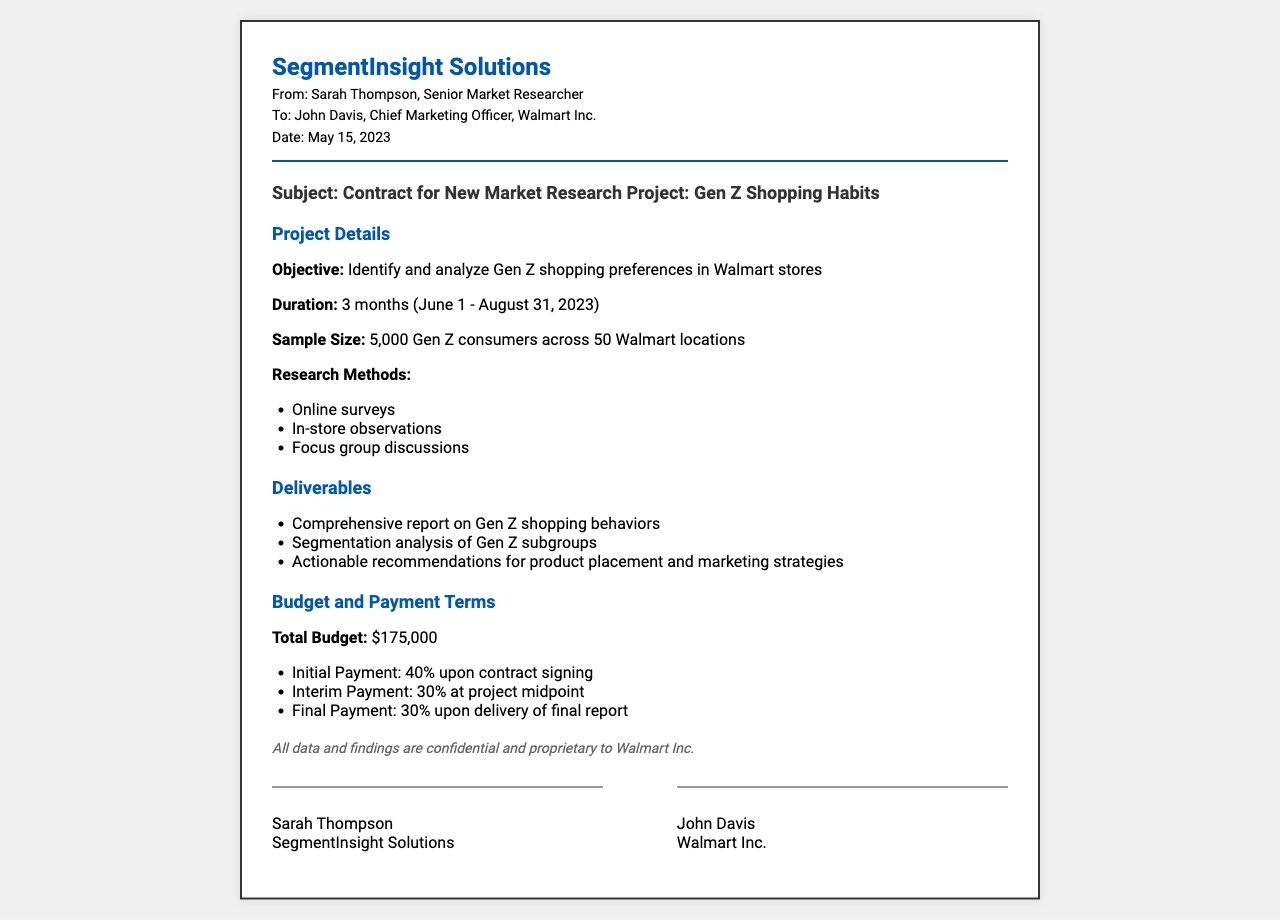What is the objective of the project? The objective is clearly stated in the document as the identification and analysis of Gen Z shopping preferences in Walmart stores.
Answer: Identify and analyze Gen Z shopping preferences in Walmart stores What is the sample size for the research? The sample size is specified in the document, listing it as the total number of Gen Z consumers involved in the study.
Answer: 5,000 Gen Z consumers When does the project duration start? The project duration section of the document states the starting date clearly.
Answer: June 1 What is the total budget for the project? The total budget figure is explicitly provided in the budget and payment terms section.
Answer: $175,000 What are the primary research methods used? The research methods outlined in the document include a list of techniques employed for the study.
Answer: Online surveys, In-store observations, Focus group discussions What payment percentage is required upon contract signing? The payment terms detail the percentages associated with each stage of payment, including the initial payment upon signing.
Answer: 40% Who is the Chief Marketing Officer at Walmart Inc.? The document lists John Davis's title and affiliation, confirming his position.
Answer: John Davis What is a deliverable from the project? The deliverables section names key outputs expected from the research effort.
Answer: Comprehensive report on Gen Z shopping behaviors Is the document confidential? The confidentiality statement within the document indicates the proprietary nature of the findings.
Answer: Yes 